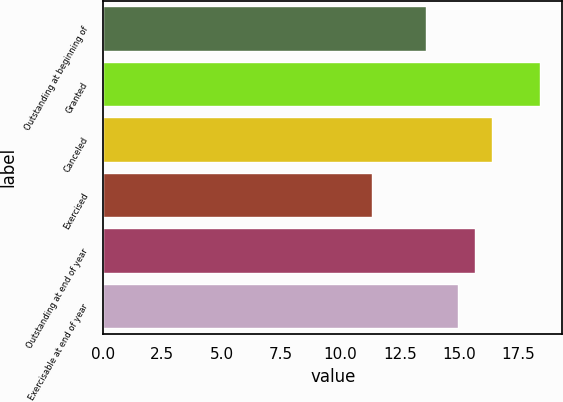Convert chart. <chart><loc_0><loc_0><loc_500><loc_500><bar_chart><fcel>Outstanding at beginning of<fcel>Granted<fcel>Canceled<fcel>Exercised<fcel>Outstanding at end of year<fcel>Exercisable at end of year<nl><fcel>13.58<fcel>18.42<fcel>16.36<fcel>11.31<fcel>15.65<fcel>14.94<nl></chart> 